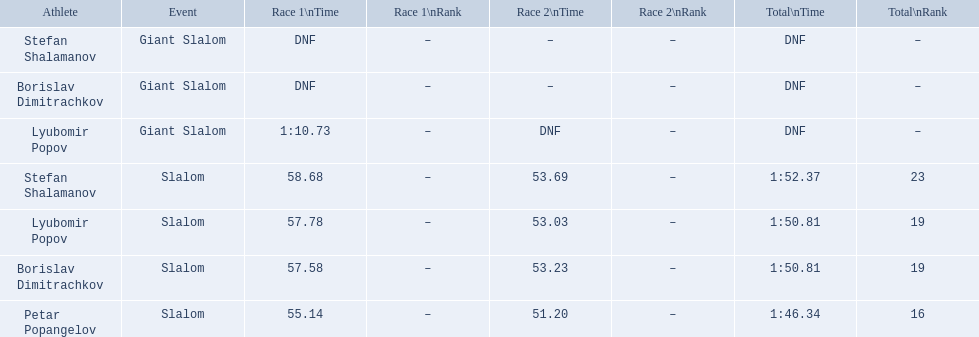What were the event names during bulgaria at the 1988 winter olympics? Stefan Shalamanov, Borislav Dimitrachkov, Lyubomir Popov. And which players participated at giant slalom? Giant Slalom, Giant Slalom, Giant Slalom, Slalom, Slalom, Slalom, Slalom. What were their race 1 times? DNF, DNF, 1:10.73. What was lyubomir popov's personal time? 1:10.73. 